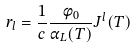Convert formula to latex. <formula><loc_0><loc_0><loc_500><loc_500>r _ { l } = \frac { 1 } { c } \frac { \phi _ { 0 } } { \alpha _ { L } ( T ) } J ^ { l } ( T )</formula> 